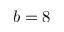<formula> <loc_0><loc_0><loc_500><loc_500>b = 8</formula> 